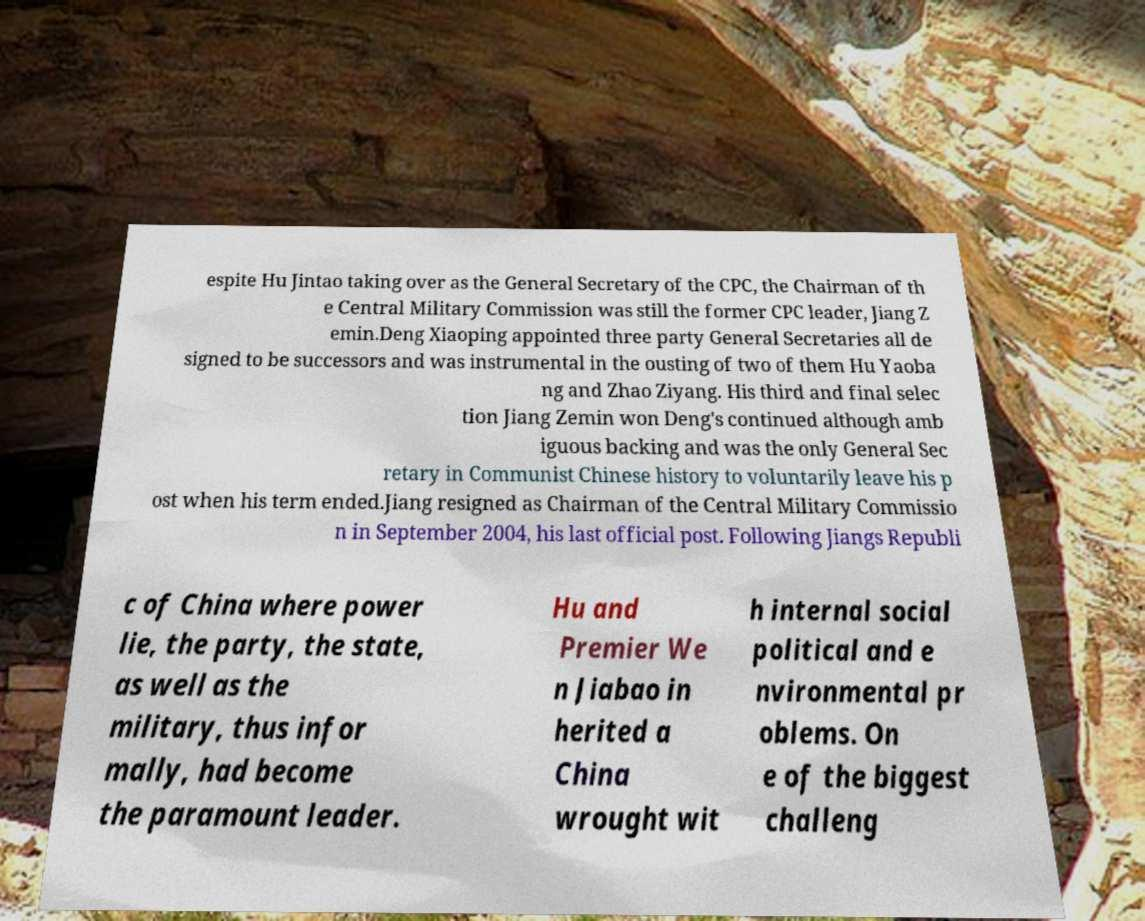Could you extract and type out the text from this image? espite Hu Jintao taking over as the General Secretary of the CPC, the Chairman of th e Central Military Commission was still the former CPC leader, Jiang Z emin.Deng Xiaoping appointed three party General Secretaries all de signed to be successors and was instrumental in the ousting of two of them Hu Yaoba ng and Zhao Ziyang. His third and final selec tion Jiang Zemin won Deng's continued although amb iguous backing and was the only General Sec retary in Communist Chinese history to voluntarily leave his p ost when his term ended.Jiang resigned as Chairman of the Central Military Commissio n in September 2004, his last official post. Following Jiangs Republi c of China where power lie, the party, the state, as well as the military, thus infor mally, had become the paramount leader. Hu and Premier We n Jiabao in herited a China wrought wit h internal social political and e nvironmental pr oblems. On e of the biggest challeng 